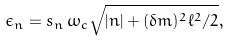<formula> <loc_0><loc_0><loc_500><loc_500>\epsilon _ { n } = s _ { n } \, \omega _ { c } \sqrt { | n | + ( \delta m ) ^ { 2 } \ell ^ { 2 } / 2 } ,</formula> 